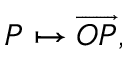Convert formula to latex. <formula><loc_0><loc_0><loc_500><loc_500>P \mapsto { \overrightarrow { O P } } ,</formula> 